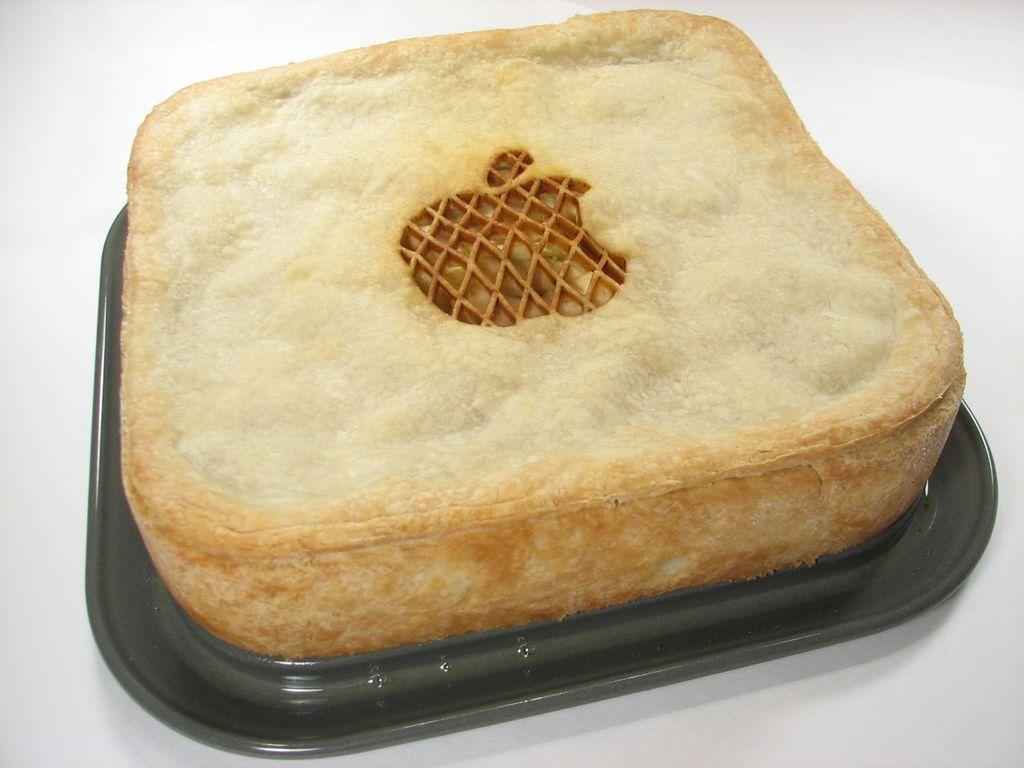What is the main subject of the image? There is a food item in the image. Where is the food item placed? The food item is placed in a black object. What type of surface is visible at the bottom of the image? There is a white surface at the bottom of the image. How many feathers can be seen resting on the food item in the image? There are no feathers present in the image. 